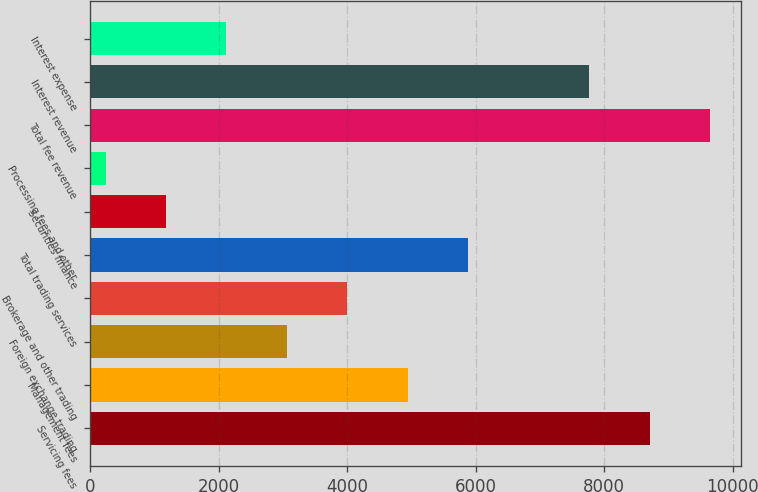Convert chart to OTSL. <chart><loc_0><loc_0><loc_500><loc_500><bar_chart><fcel>Servicing fees<fcel>Management fees<fcel>Foreign exchange trading<fcel>Brokerage and other trading<fcel>Total trading services<fcel>Securities finance<fcel>Processing fees and other<fcel>Total fee revenue<fcel>Interest revenue<fcel>Interest expense<nl><fcel>8708.1<fcel>4944.5<fcel>3062.7<fcel>4003.6<fcel>5885.4<fcel>1180.9<fcel>240<fcel>9649<fcel>7767.2<fcel>2121.8<nl></chart> 